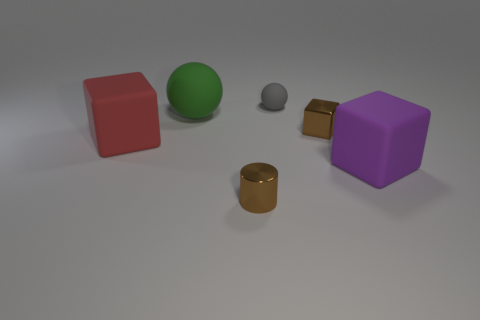What is the color of the other rubber object that is the same shape as the small gray object?
Provide a short and direct response. Green. What is the shape of the small brown thing in front of the purple rubber thing?
Ensure brevity in your answer.  Cylinder. Are there any tiny metallic objects in front of the tiny metal block?
Your answer should be compact. Yes. There is a big sphere that is the same material as the large red object; what color is it?
Provide a short and direct response. Green. There is a metallic object that is in front of the purple thing; is it the same color as the tiny shiny thing that is behind the tiny brown cylinder?
Make the answer very short. Yes. How many cubes are either big rubber objects or brown things?
Keep it short and to the point. 3. Are there an equal number of big objects left of the shiny block and rubber balls?
Give a very brief answer. Yes. What is the brown object that is behind the purple matte object in front of the tiny gray sphere that is to the right of the red object made of?
Your response must be concise. Metal. There is a tiny block that is the same color as the small cylinder; what is it made of?
Offer a terse response. Metal. What number of things are either rubber cubes right of the small gray object or tiny cubes?
Provide a succinct answer. 2. 